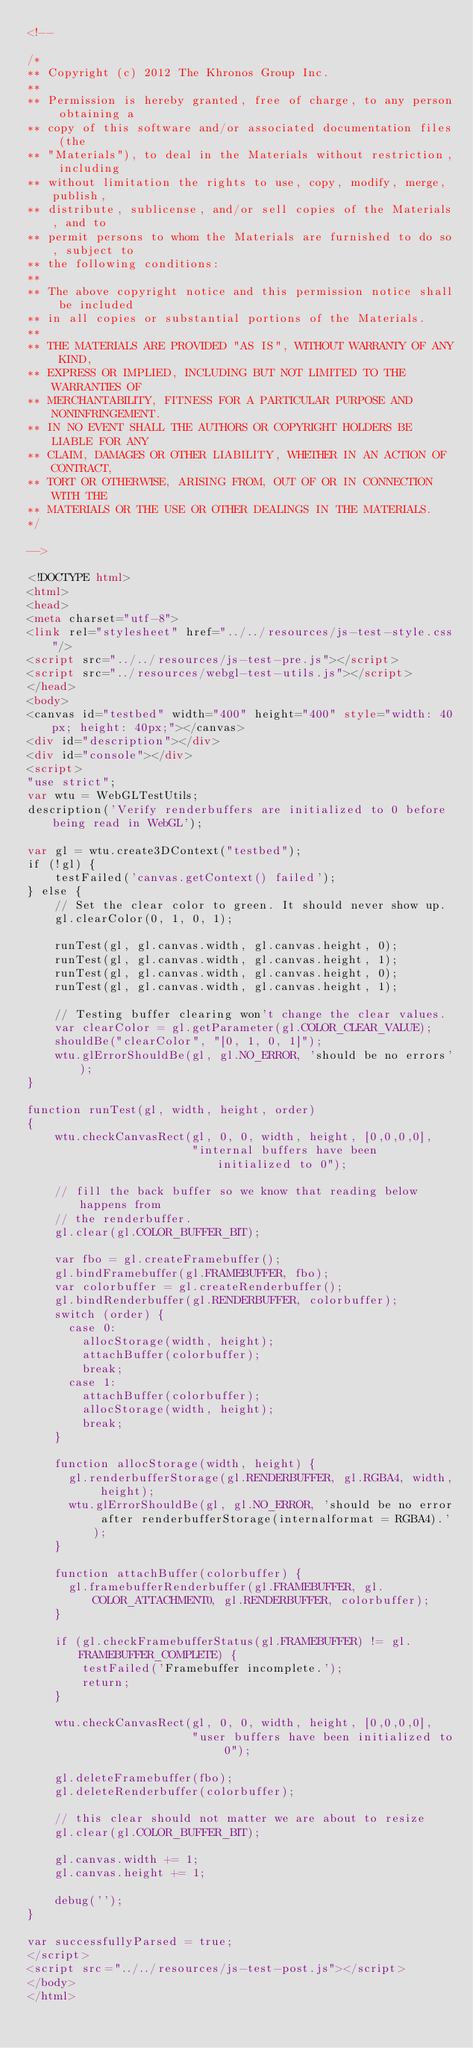<code> <loc_0><loc_0><loc_500><loc_500><_HTML_><!--

/*
** Copyright (c) 2012 The Khronos Group Inc.
**
** Permission is hereby granted, free of charge, to any person obtaining a
** copy of this software and/or associated documentation files (the
** "Materials"), to deal in the Materials without restriction, including
** without limitation the rights to use, copy, modify, merge, publish,
** distribute, sublicense, and/or sell copies of the Materials, and to
** permit persons to whom the Materials are furnished to do so, subject to
** the following conditions:
**
** The above copyright notice and this permission notice shall be included
** in all copies or substantial portions of the Materials.
**
** THE MATERIALS ARE PROVIDED "AS IS", WITHOUT WARRANTY OF ANY KIND,
** EXPRESS OR IMPLIED, INCLUDING BUT NOT LIMITED TO THE WARRANTIES OF
** MERCHANTABILITY, FITNESS FOR A PARTICULAR PURPOSE AND NONINFRINGEMENT.
** IN NO EVENT SHALL THE AUTHORS OR COPYRIGHT HOLDERS BE LIABLE FOR ANY
** CLAIM, DAMAGES OR OTHER LIABILITY, WHETHER IN AN ACTION OF CONTRACT,
** TORT OR OTHERWISE, ARISING FROM, OUT OF OR IN CONNECTION WITH THE
** MATERIALS OR THE USE OR OTHER DEALINGS IN THE MATERIALS.
*/

-->

<!DOCTYPE html>
<html>
<head>
<meta charset="utf-8">
<link rel="stylesheet" href="../../resources/js-test-style.css"/>
<script src="../../resources/js-test-pre.js"></script>
<script src="../resources/webgl-test-utils.js"></script>
</head>
<body>
<canvas id="testbed" width="400" height="400" style="width: 40px; height: 40px;"></canvas>
<div id="description"></div>
<div id="console"></div>
<script>
"use strict";
var wtu = WebGLTestUtils;
description('Verify renderbuffers are initialized to 0 before being read in WebGL');

var gl = wtu.create3DContext("testbed");
if (!gl) {
    testFailed('canvas.getContext() failed');
} else {
    // Set the clear color to green. It should never show up.
    gl.clearColor(0, 1, 0, 1);

    runTest(gl, gl.canvas.width, gl.canvas.height, 0);
    runTest(gl, gl.canvas.width, gl.canvas.height, 1);
    runTest(gl, gl.canvas.width, gl.canvas.height, 0);
    runTest(gl, gl.canvas.width, gl.canvas.height, 1);

    // Testing buffer clearing won't change the clear values.
    var clearColor = gl.getParameter(gl.COLOR_CLEAR_VALUE);
    shouldBe("clearColor", "[0, 1, 0, 1]");
    wtu.glErrorShouldBe(gl, gl.NO_ERROR, 'should be no errors');
}

function runTest(gl, width, height, order)
{
    wtu.checkCanvasRect(gl, 0, 0, width, height, [0,0,0,0],
                        "internal buffers have been initialized to 0");

    // fill the back buffer so we know that reading below happens from
    // the renderbuffer.
    gl.clear(gl.COLOR_BUFFER_BIT);

    var fbo = gl.createFramebuffer();
    gl.bindFramebuffer(gl.FRAMEBUFFER, fbo);
    var colorbuffer = gl.createRenderbuffer();
    gl.bindRenderbuffer(gl.RENDERBUFFER, colorbuffer);
    switch (order) {
      case 0:
        allocStorage(width, height);
        attachBuffer(colorbuffer);
        break;
      case 1:
        attachBuffer(colorbuffer);
        allocStorage(width, height);
        break;
    }

    function allocStorage(width, height) {
      gl.renderbufferStorage(gl.RENDERBUFFER, gl.RGBA4, width, height);
      wtu.glErrorShouldBe(gl, gl.NO_ERROR, 'should be no error after renderbufferStorage(internalformat = RGBA4).');
    }

    function attachBuffer(colorbuffer) {
      gl.framebufferRenderbuffer(gl.FRAMEBUFFER, gl.COLOR_ATTACHMENT0, gl.RENDERBUFFER, colorbuffer);
    }

    if (gl.checkFramebufferStatus(gl.FRAMEBUFFER) != gl.FRAMEBUFFER_COMPLETE) {
        testFailed('Framebuffer incomplete.');
        return;
    }

    wtu.checkCanvasRect(gl, 0, 0, width, height, [0,0,0,0],
                        "user buffers have been initialized to 0");

    gl.deleteFramebuffer(fbo);
    gl.deleteRenderbuffer(colorbuffer);

    // this clear should not matter we are about to resize
    gl.clear(gl.COLOR_BUFFER_BIT);

    gl.canvas.width += 1;
    gl.canvas.height += 1;

    debug('');
}

var successfullyParsed = true;
</script>
<script src="../../resources/js-test-post.js"></script>
</body>
</html>
</code> 